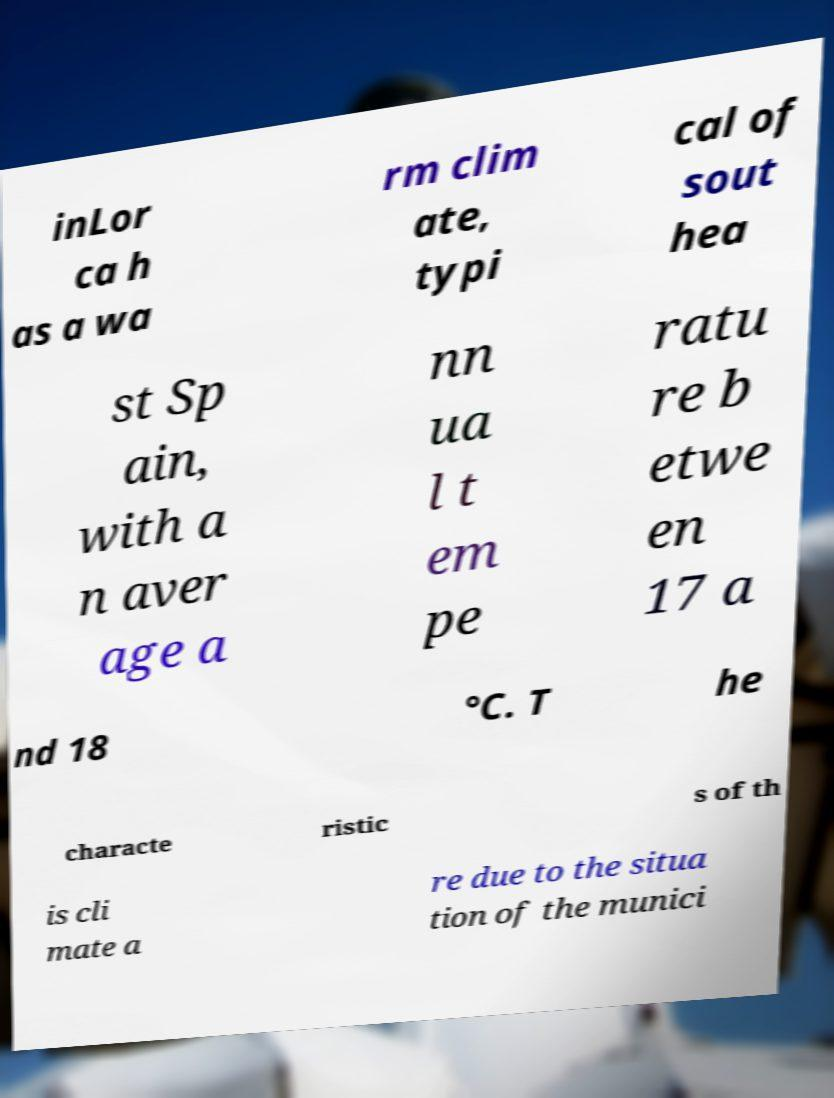Could you extract and type out the text from this image? inLor ca h as a wa rm clim ate, typi cal of sout hea st Sp ain, with a n aver age a nn ua l t em pe ratu re b etwe en 17 a nd 18 °C. T he characte ristic s of th is cli mate a re due to the situa tion of the munici 